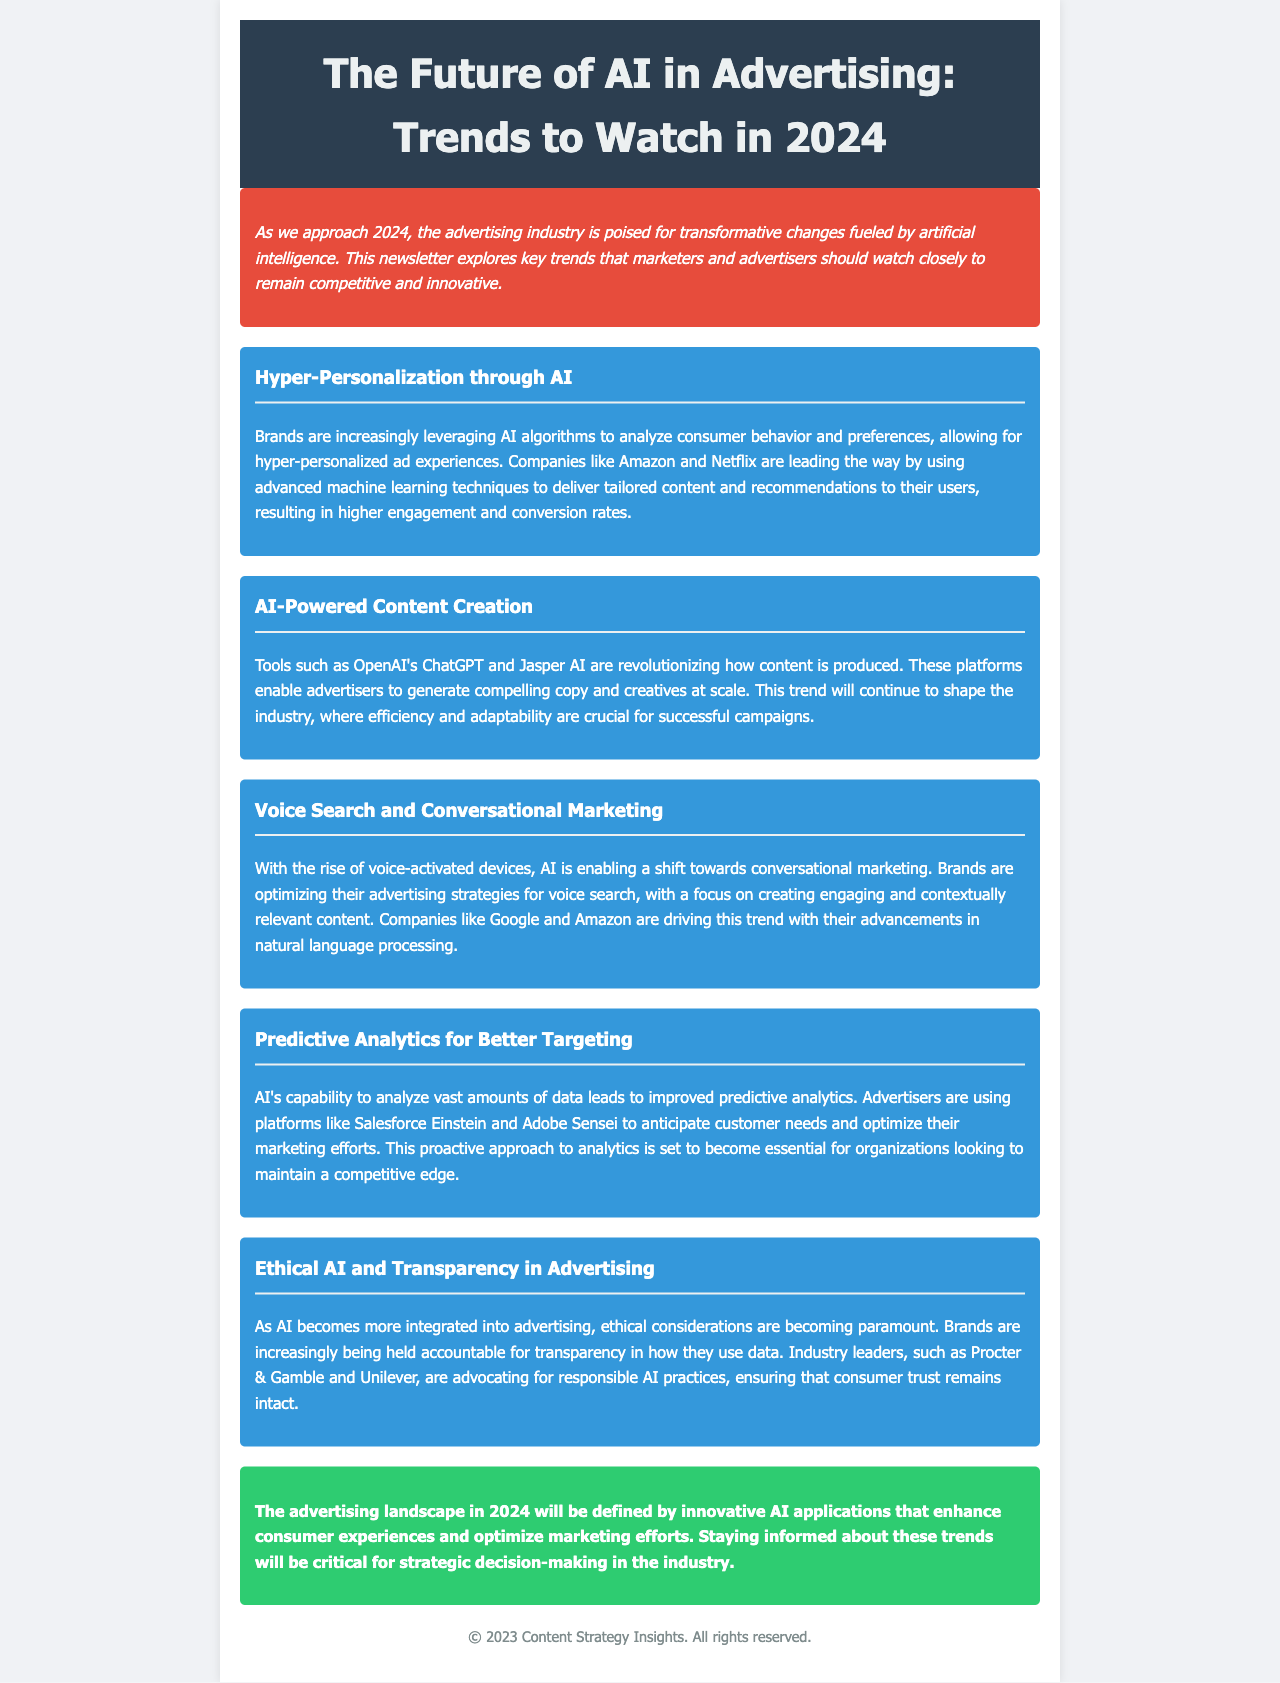What is the title of the newsletter? The title can be found in the header of the document, and it is "The Future of AI in Advertising: Trends to Watch in 2024."
Answer: The Future of AI in Advertising: Trends to Watch in 2024 What color is the background of the introduction section? The introduction section has a specific background color that is mentioned in the document, which is red.
Answer: Red Which company is mentioned as a leader in hyper-personalization? The document identifies a specific company known for this trend, which is Amazon.
Answer: Amazon What AI tool is mentioned for content creation? The document lists specific tools used for content creation, including OpenAI's ChatGPT.
Answer: OpenAI's ChatGPT How many trends are discussed in the document? The document outlines a specific number of trends, which is five.
Answer: Five What ethical concern is highlighted in the document? The document discusses the importance of transparency as an ethical concern in advertising.
Answer: Transparency What is the conclusion color in the newsletter? The conclusion section has a distinctive background color mentioned in the document, which is green.
Answer: Green Name one company advocating for responsible AI practices. The document states that Procter & Gamble is a leader in advocating responsible AI practices.
Answer: Procter & Gamble 